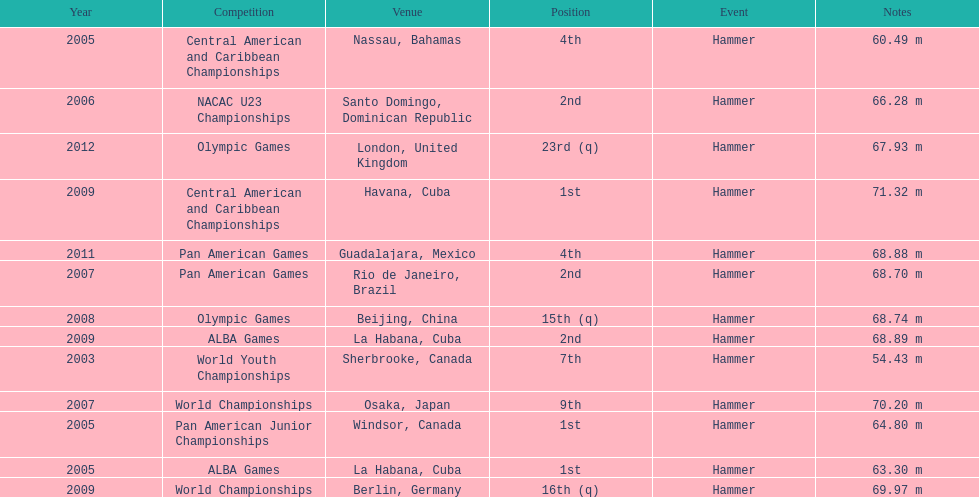In which olympic games did arasay thondike not finish in the top 20? 2012. 